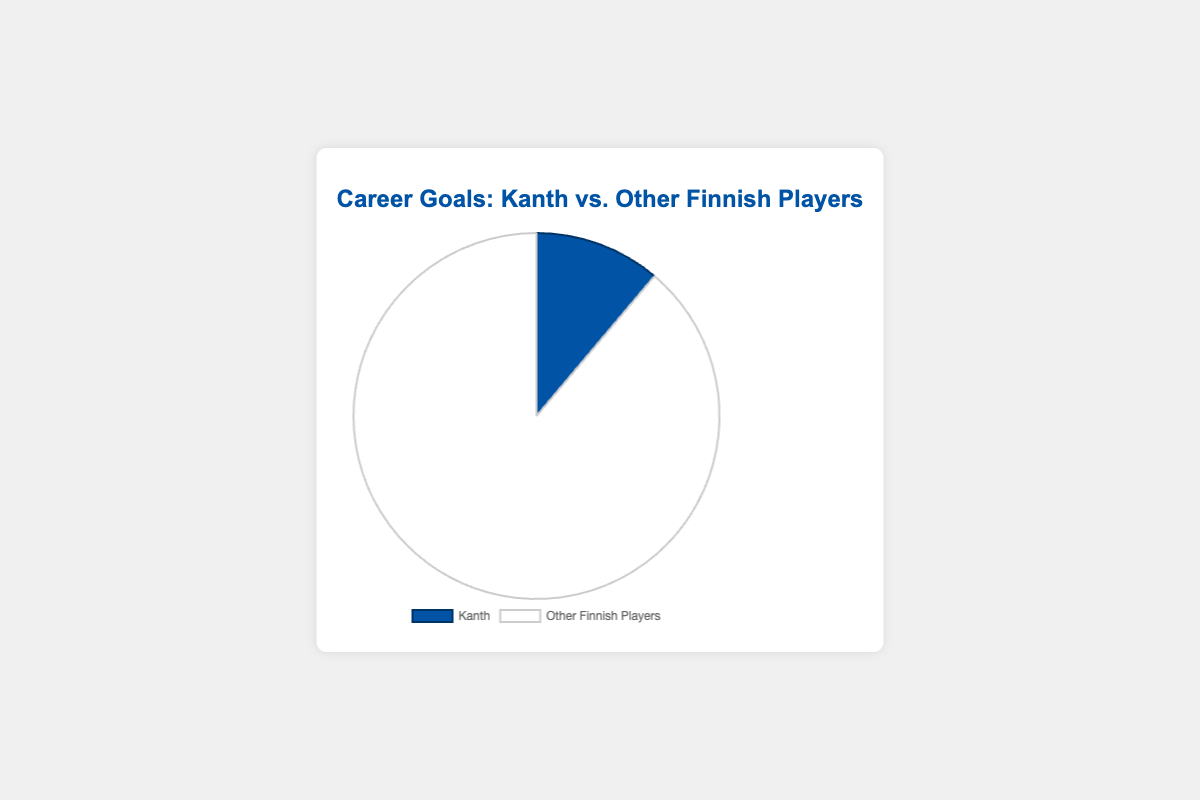Which player has scored more goals? The figure shows two segments: one for Kanth with 123 goals and another for Other Finnish Players with 980 goals. Comparing these, the Other Finnish Players have more goals.
Answer: Other Finnish Players By how many goals do Other Finnish Players outperform Kanth? The Other Finnish Players have 980 goals, and Kanth has 123 goals. The difference is calculated by subtracting Kanth's goals from the Other Finnish Players' goals: 980 - 123 = 857 goals.
Answer: 857 What percentage of the total goals does Kanth represent? To calculate the percentage, first find the total number of goals: 123 (Kanth) + 980 (Other Finnish Players) = 1103 goals. Then, divide Kanth's goals by the total and multiply by 100: (123 / 1103) * 100 ≈ 11.15%.
Answer: 11.15% How much larger is the Other Finnish Players' segment compared to Kanth’s in terms of color proportion? Visually, it can be observed that the Other Finnish Players' segment (white color) takes up significantly more space compared to Kanth's segment (blue color), indicating a higher proportion of goals. The exact value can be derived by comparing percentages: roughly 88.85% (Other Finnish Players) vs. 11.15% (Kanth).
Answer: Roughly 88.85% Calculate the average number of goals for each data set represented in the pie chart. There are two data points: Kanth with 123 goals and Other Finnish Players with 980 goals. The average can be calculated by summing the goals and dividing by the number of datasets: (123 + 980) / 2 = 1103 / 2 = 551.5 goals.
Answer: 551.5 What is the ratio of goals scored by Kanth to those scored by Other Finnish Players? The number of goals by Kanth is 123 and by Other Finnish Players is 980. The ratio is calculated by dividing Kanth's goals by Other Finnish Players' goals: 123 / 980 ≈ 0.125.
Answer: 0.125 If Kanth's goals increased by 50%, what would his new total be? Kanth's current goals are 123. A 50% increase is calculated as 123 * 0.5 = 61.5. Adding this to the original total: 123 + 61.5 = 184.5 goals.
Answer: 184.5 Determine the total number of goals scored. Sum the goals scored by both Kanth and Other Finnish Players: 123 + 980 = 1103 goals.
Answer: 1103 If the total goals scored were divided equally among Kanth and Other Finnish Players, how many goals would each have? The total goals are 1103. Dividing this equally between two groups, we get 1103 / 2 = 551.5 goals each.
Answer: 551.5 